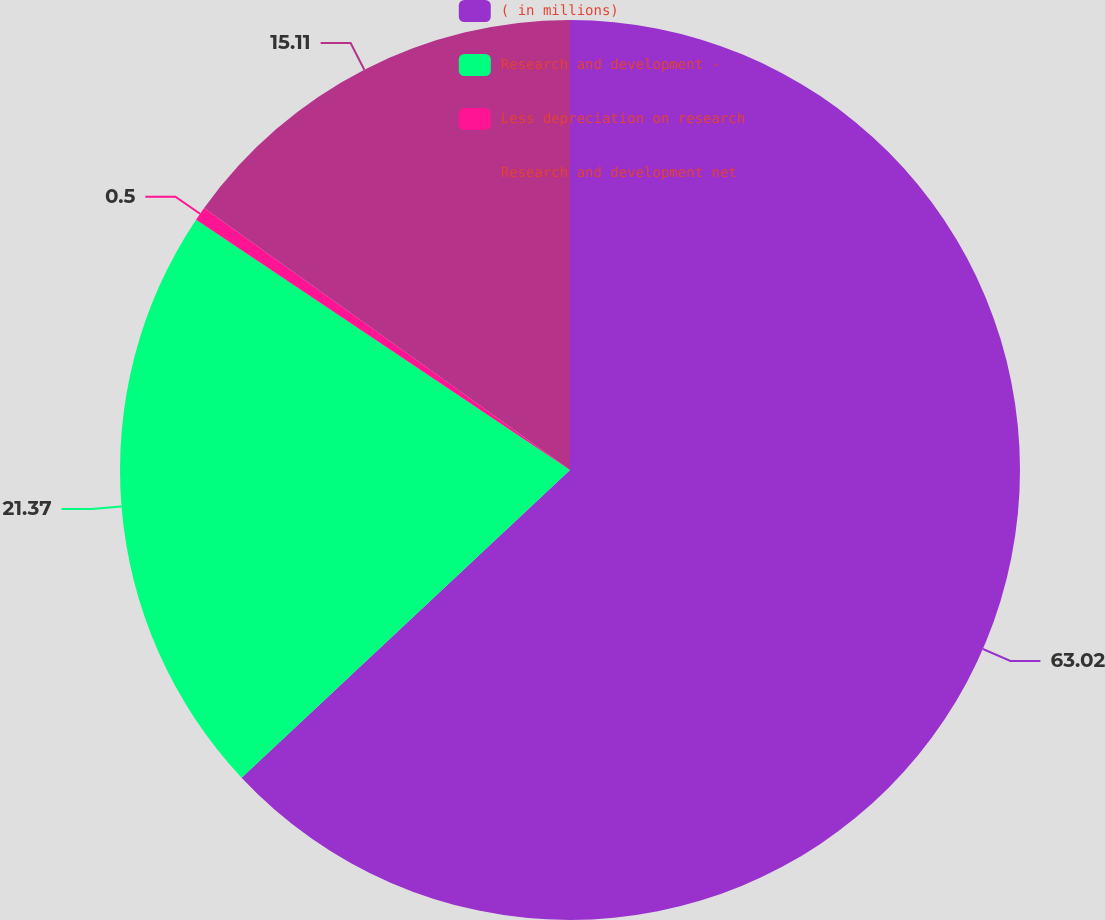Convert chart. <chart><loc_0><loc_0><loc_500><loc_500><pie_chart><fcel>( in millions)<fcel>Research and development -<fcel>Less depreciation on research<fcel>Research and development net<nl><fcel>63.02%<fcel>21.37%<fcel>0.5%<fcel>15.11%<nl></chart> 